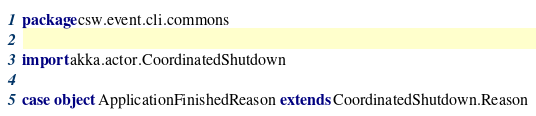<code> <loc_0><loc_0><loc_500><loc_500><_Scala_>package csw.event.cli.commons

import akka.actor.CoordinatedShutdown

case object ApplicationFinishedReason extends CoordinatedShutdown.Reason
</code> 